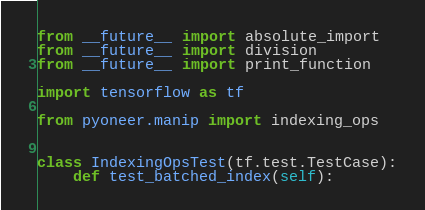Convert code to text. <code><loc_0><loc_0><loc_500><loc_500><_Python_>from __future__ import absolute_import
from __future__ import division
from __future__ import print_function

import tensorflow as tf

from pyoneer.manip import indexing_ops


class IndexingOpsTest(tf.test.TestCase):
    def test_batched_index(self):</code> 